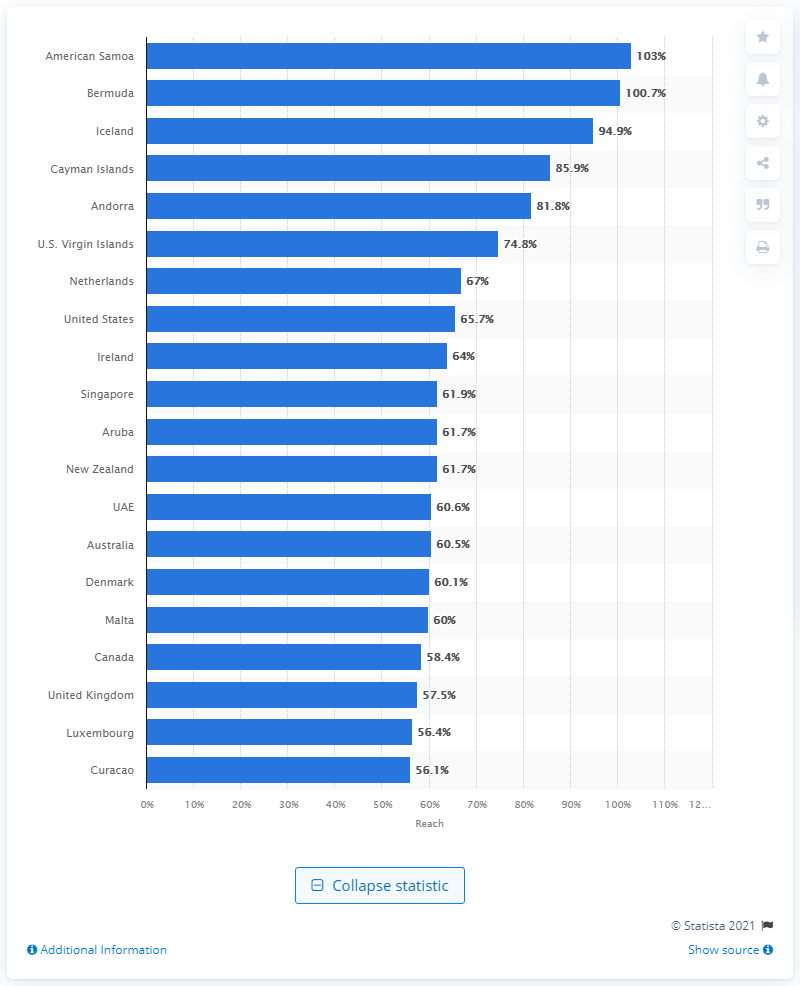Mention a couple of crucial points in this snapshot. As of April 2021, LinkedIn had a reach of almost 101% in Bermuda. 